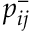<formula> <loc_0><loc_0><loc_500><loc_500>p _ { i j } ^ { - }</formula> 